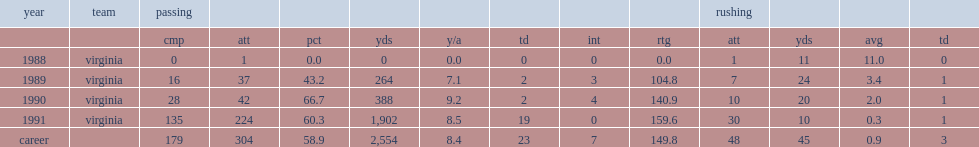How many passes did blundin throw during the 1991 season? 224.0. 